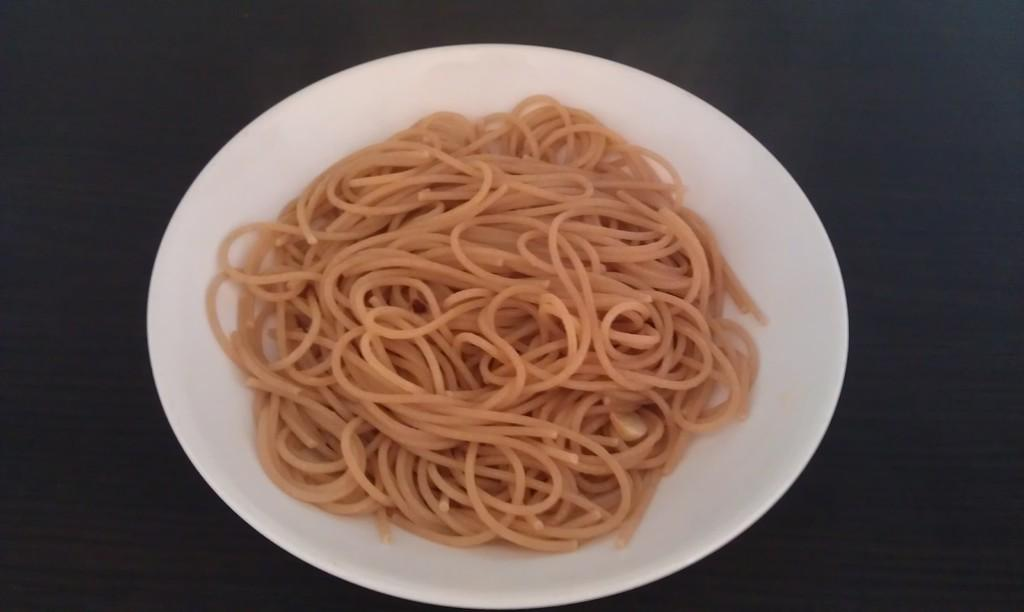What type of food is in the bowl in the image? There are noodles in a white bowl. What color is the bowl? The bowl is white. What is the bowl placed on in the image? The bowl is on a black surface. How many books are stacked on the field in the image? There are no books or fields present in the image; it only features a bowl of noodles on a black surface. 